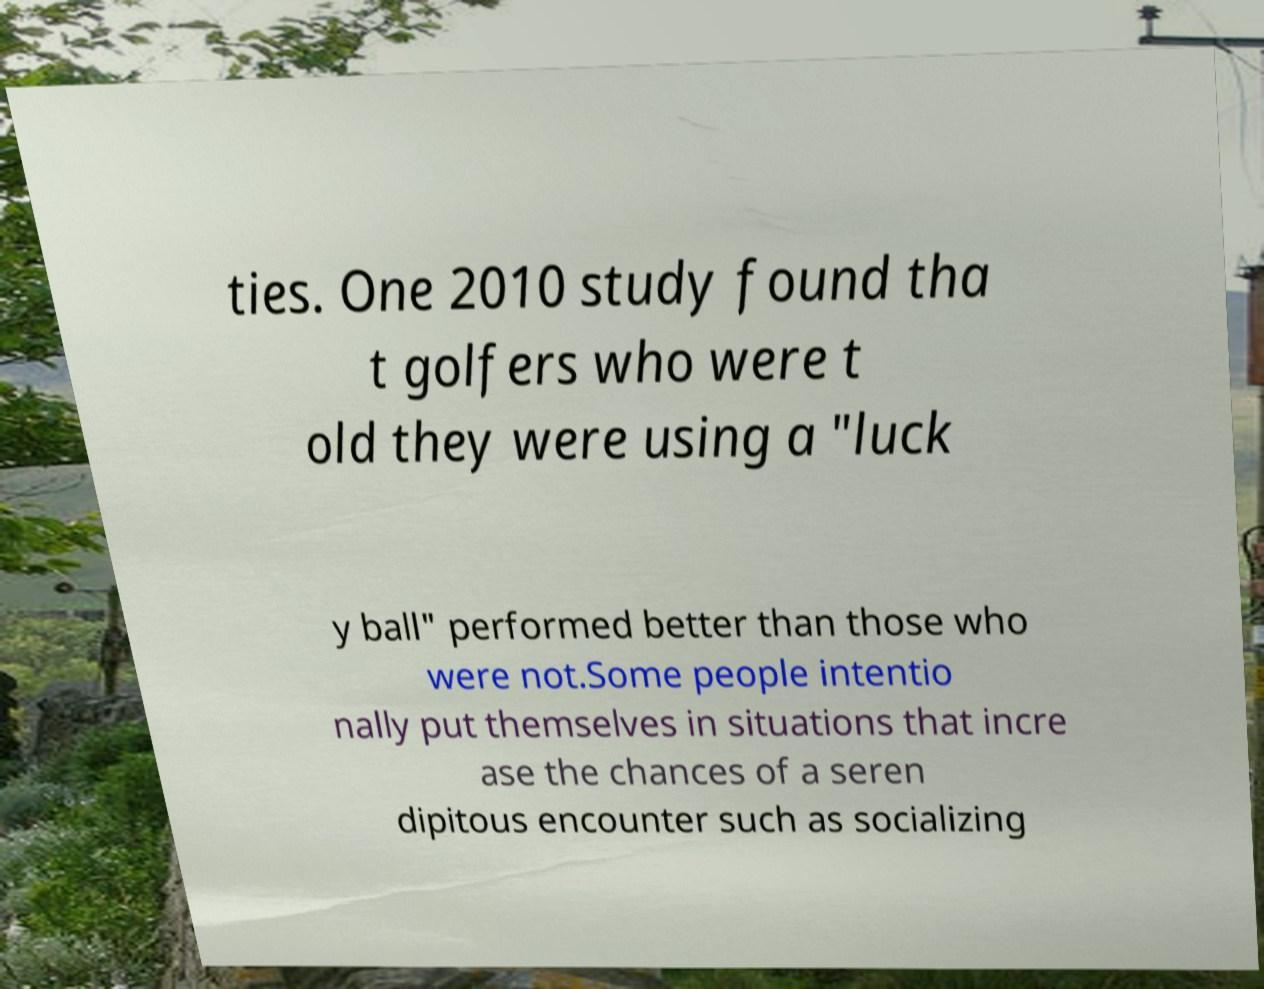Please identify and transcribe the text found in this image. ties. One 2010 study found tha t golfers who were t old they were using a "luck y ball" performed better than those who were not.Some people intentio nally put themselves in situations that incre ase the chances of a seren dipitous encounter such as socializing 